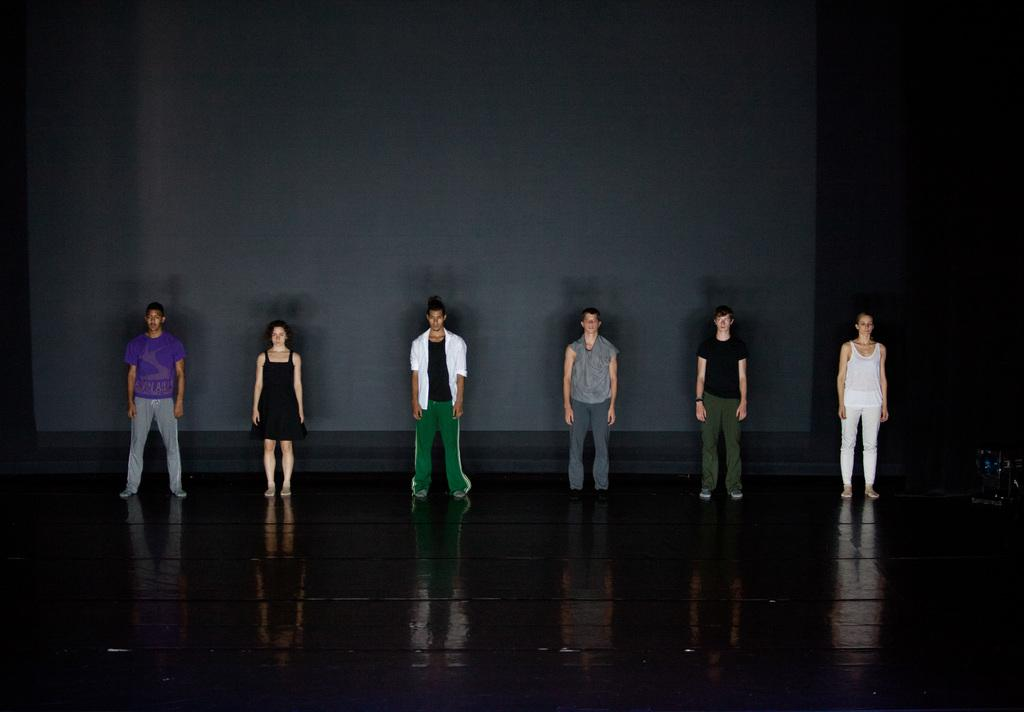How many people are in the image? The number of people in the image is not specified, but there are people present. What is the people's position in the image? The people are standing on the floor in the image. What type of can is being used by the people in the image? There is no can present in the image; the people are standing on the floor. 